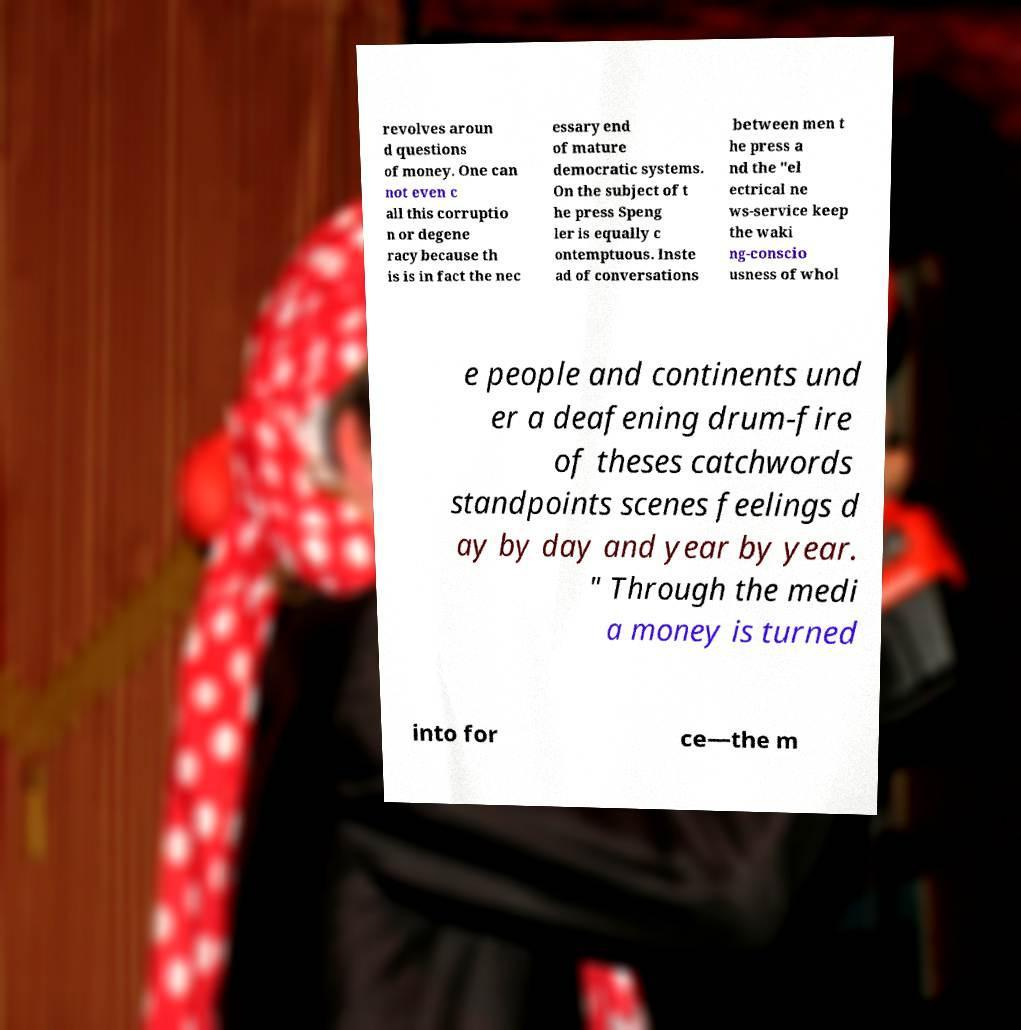There's text embedded in this image that I need extracted. Can you transcribe it verbatim? revolves aroun d questions of money. One can not even c all this corruptio n or degene racy because th is is in fact the nec essary end of mature democratic systems. On the subject of t he press Speng ler is equally c ontemptuous. Inste ad of conversations between men t he press a nd the "el ectrical ne ws-service keep the waki ng-conscio usness of whol e people and continents und er a deafening drum-fire of theses catchwords standpoints scenes feelings d ay by day and year by year. " Through the medi a money is turned into for ce—the m 